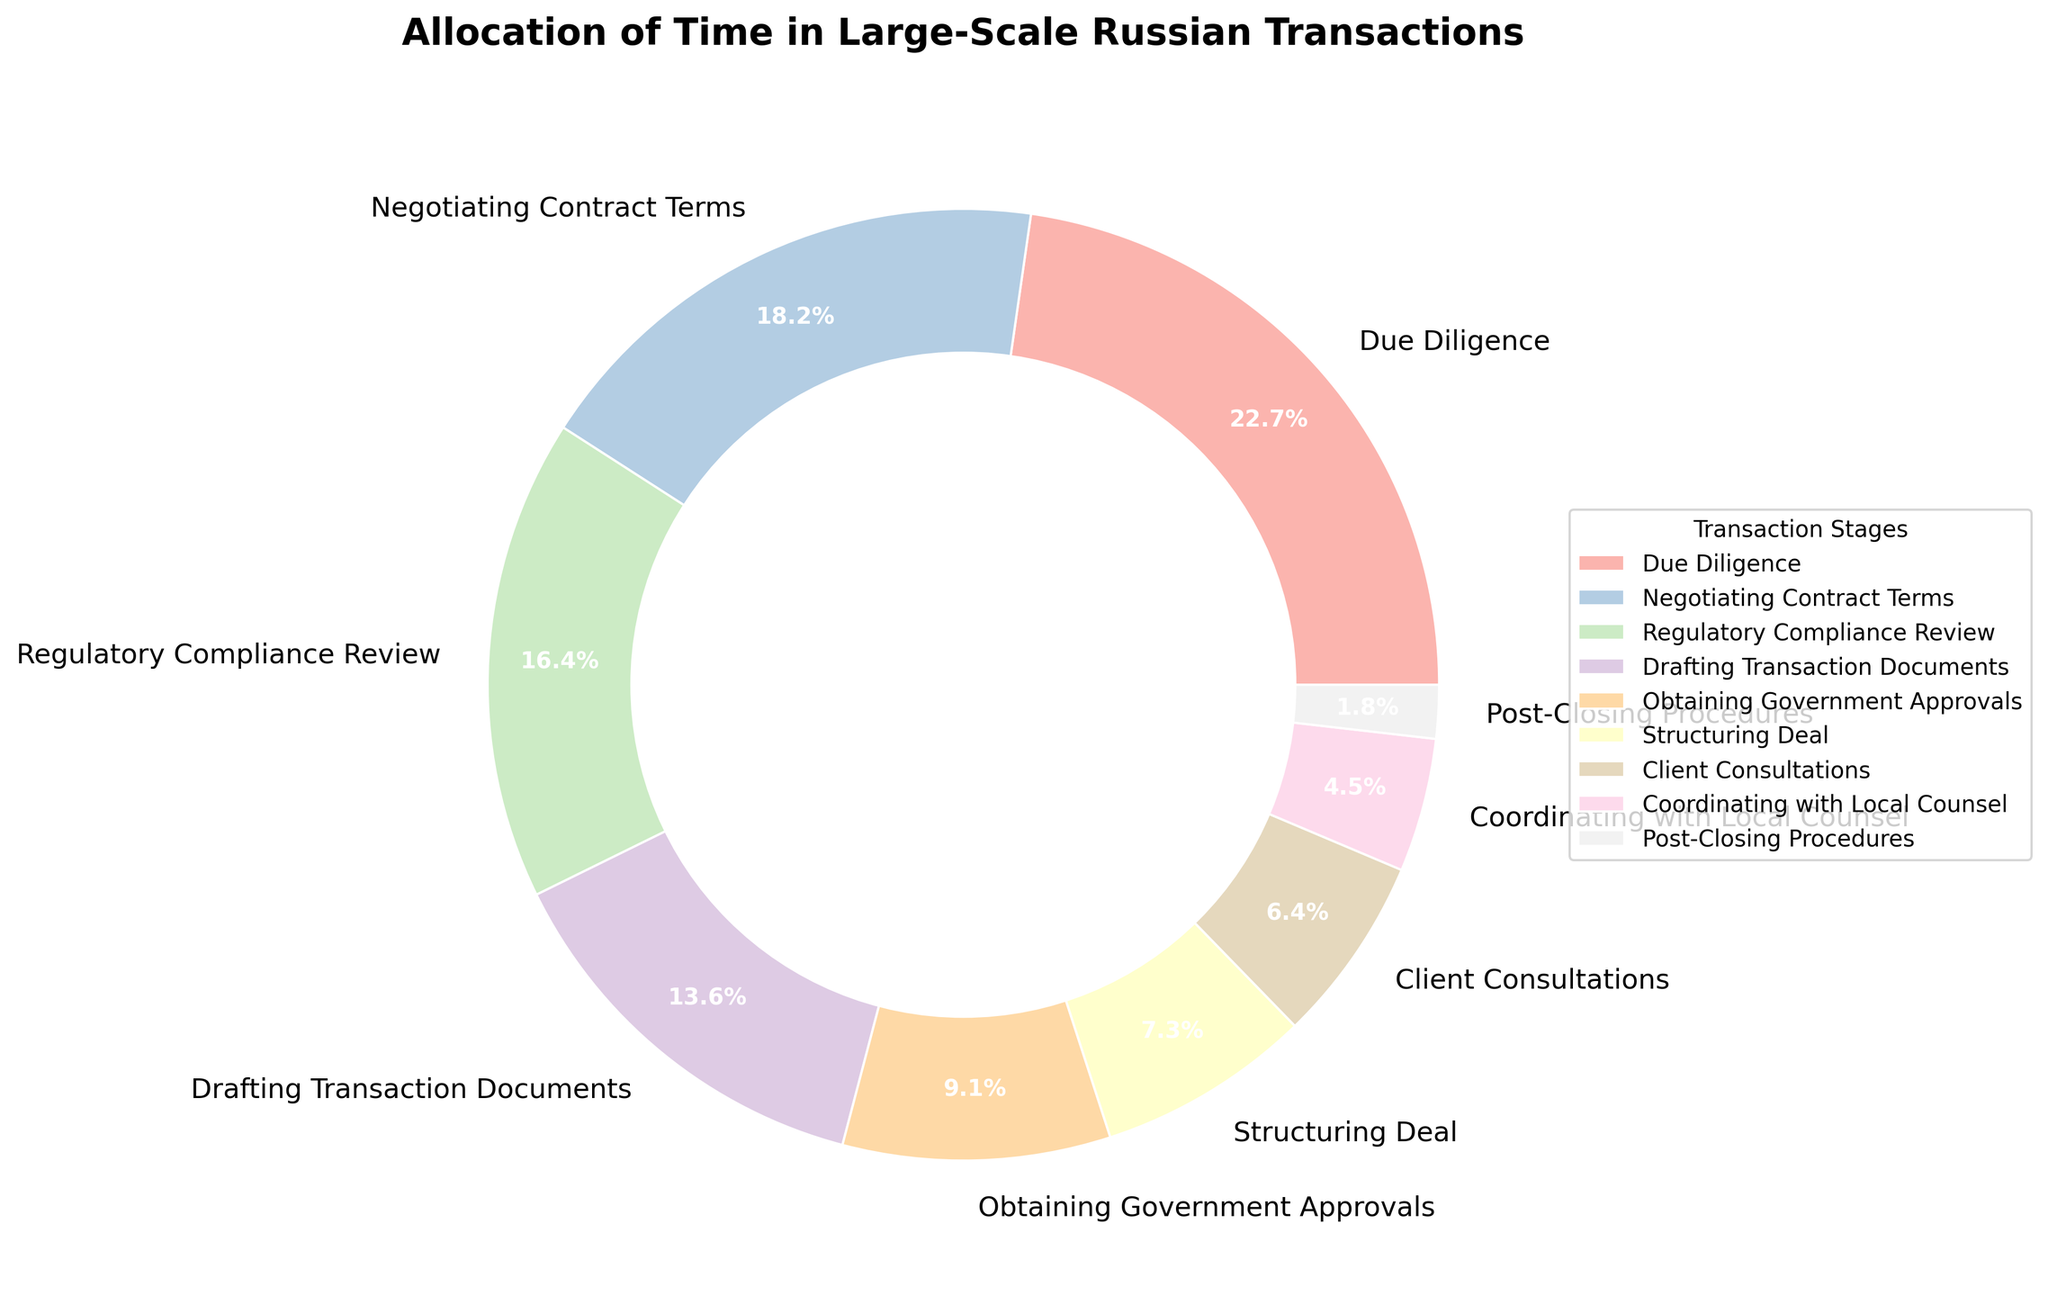What's the most time-consuming stage of a large-scale transaction in Russia? The figure shows various stages with their corresponding percentage allocations. The "Due Diligence" stage has the highest percentage.
Answer: Due Diligence Which stage requires more time, Client Consultations or Structuring Deal? Observe the percentage allocated to each stage in the figure. Client Consultations has 7% while Structuring Deal has 8%.
Answer: Structuring Deal What percentage of time is spent on stages involving government interaction, such as Regulatory Compliance Review and Obtaining Government Approvals combined? Regulatory Compliance Review is allocated 18% and Obtaining Government Approvals is allocated 10%. Adding these two gives 18% + 10% = 28%.
Answer: 28% How much more time is spent on Negotiating Contract Terms compared to Post-Closing Procedures? Negotiating Contract Terms has 20% while Post-Closing Procedures has 2%. The difference is 20% - 2% = 18%.
Answer: 18% If you were to add the time spent on Drafting Transaction Documents and Coordinating with Local Counsel, would it exceed the time spent on Regulatory Compliance Review? Drafting Transaction Documents is 15% and Coordinating with Local Counsel is 5%. Adding these gives 15% + 5% = 20%, which is more than the Regulatory Compliance Review's 18%.
Answer: Yes Which stages involve preparing or discussing documents, and what's the combined percentage of time spent on these stages? The stages are Drafting Transaction Documents (15%) and Negotiating Contract Terms (20%). The total time is 15% + 20% = 35%.
Answer: 35% Is more time allocated to structuring the deal or coordinating with local counsel? Structuring Deal has 8% while Coordinating with Local Counsel is 5%.
Answer: Structuring Deal What is the combined percentage of time spent on stages that require direct client interactions (excluding internal team or regulatory bodies)? Client Consultations is 7%. No other stages are explicitly client-focused.
Answer: 7% If the time spent on Regulatory Compliance Review were doubled, would it surpass the time currently spent on Negotiating Contract Terms? Doubling Regulatory Compliance Review's 18% gives 36%. Since Negotiating Contract Terms is 20%, 36% is indeed greater than 20%.
Answer: Yes 